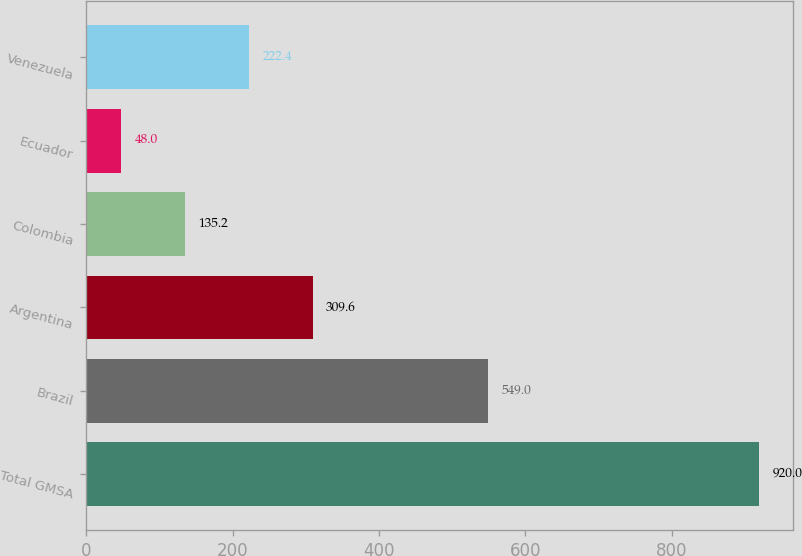Convert chart. <chart><loc_0><loc_0><loc_500><loc_500><bar_chart><fcel>Total GMSA<fcel>Brazil<fcel>Argentina<fcel>Colombia<fcel>Ecuador<fcel>Venezuela<nl><fcel>920<fcel>549<fcel>309.6<fcel>135.2<fcel>48<fcel>222.4<nl></chart> 